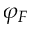<formula> <loc_0><loc_0><loc_500><loc_500>\varphi _ { F }</formula> 